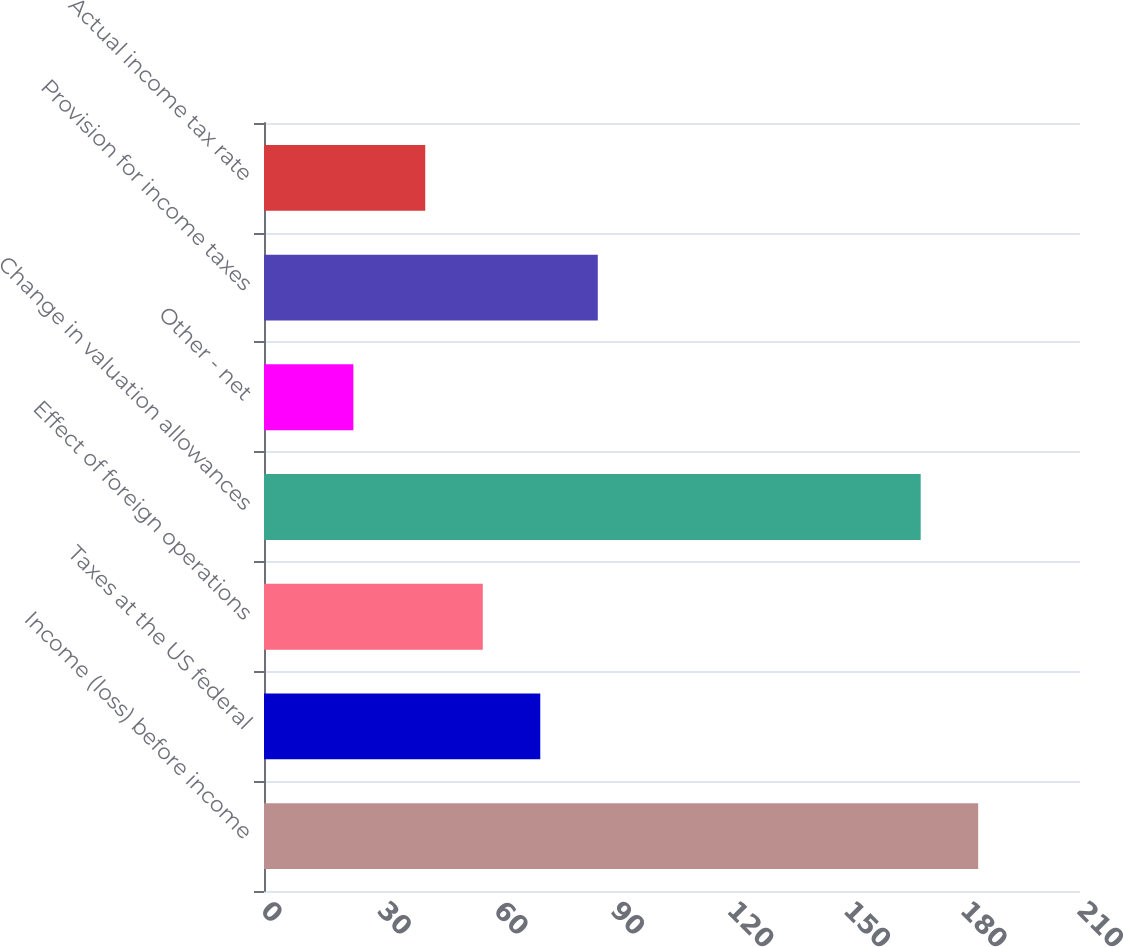Convert chart. <chart><loc_0><loc_0><loc_500><loc_500><bar_chart><fcel>Income (loss) before income<fcel>Taxes at the US federal<fcel>Effect of foreign operations<fcel>Change in valuation allowances<fcel>Other - net<fcel>Provision for income taxes<fcel>Actual income tax rate<nl><fcel>183.8<fcel>71.1<fcel>56.3<fcel>169<fcel>23<fcel>85.9<fcel>41.5<nl></chart> 